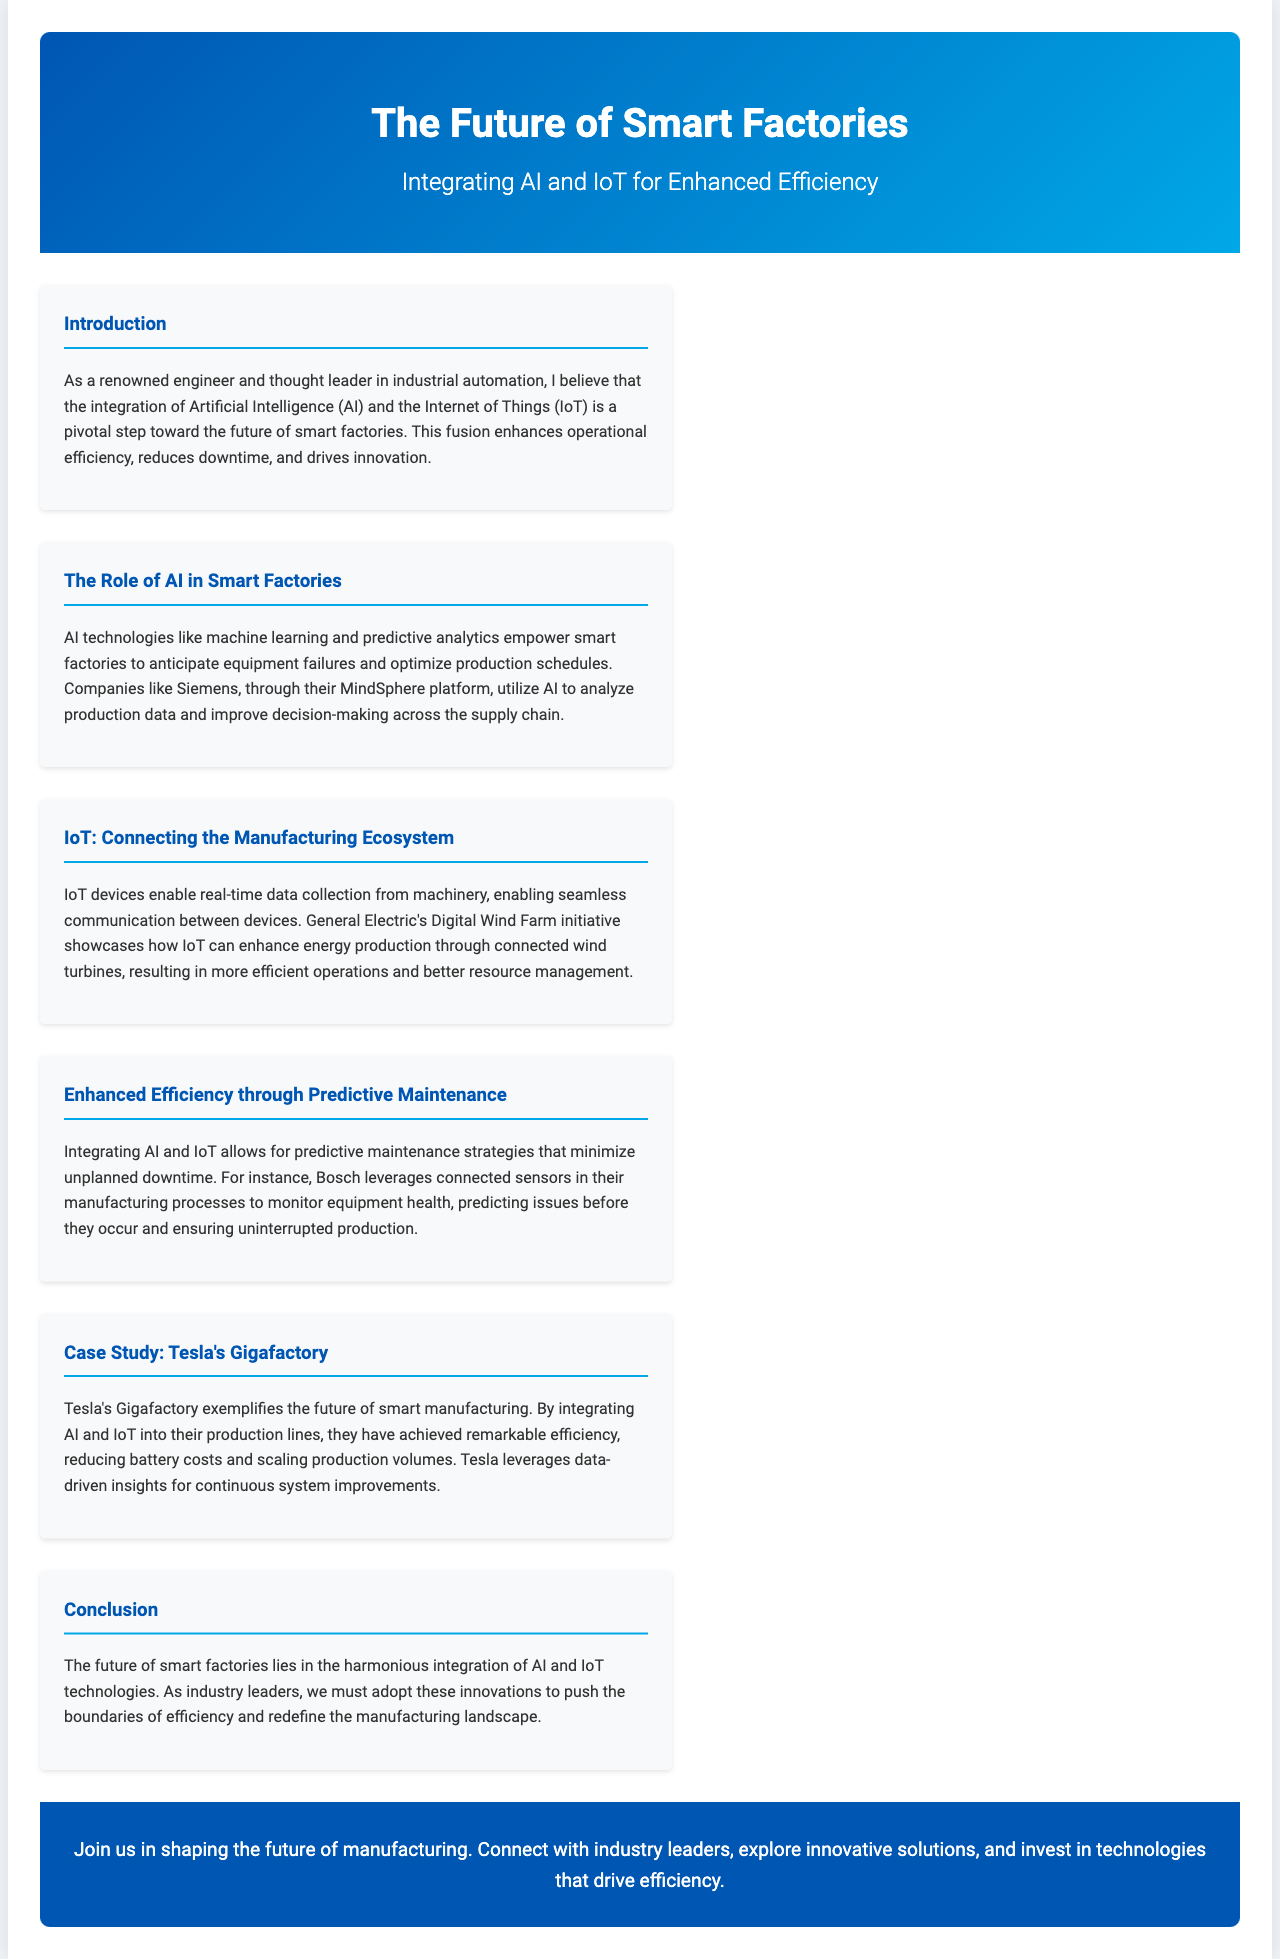what is the title of the brochure? The title of the brochure is presented prominently at the top of the document.
Answer: The Future of Smart Factories who is mentioned as a thought leader in industrial automation? The document introduces a key figure in industrial automation at the beginning.
Answer: A renowned engineer what AI platform does Siemens use? The document specifies a platform utilized by Siemens for AI analysis.
Answer: MindSphere which company’s initiative showcases IoT for energy production? The brochure highlights an initiative by a major company related to the IoT in energy.
Answer: General Electric what is a key benefit of integrating AI and IoT mentioned in the document? The document lists several advantages, focusing on a significant operational improvement.
Answer: Enhanced efficiency which manufacturing facility is used as a case study? The brochure includes a specific facility as an example of smart manufacturing.
Answer: Tesla's Gigafactory what strategy is emphasized for minimizing unplanned downtime? The document discusses a particular maintenance approach to improve operational reliability.
Answer: Predictive maintenance what color is the background of the CTA section? The brochure design includes specific background colors for thematic sections.
Answer: Blue 